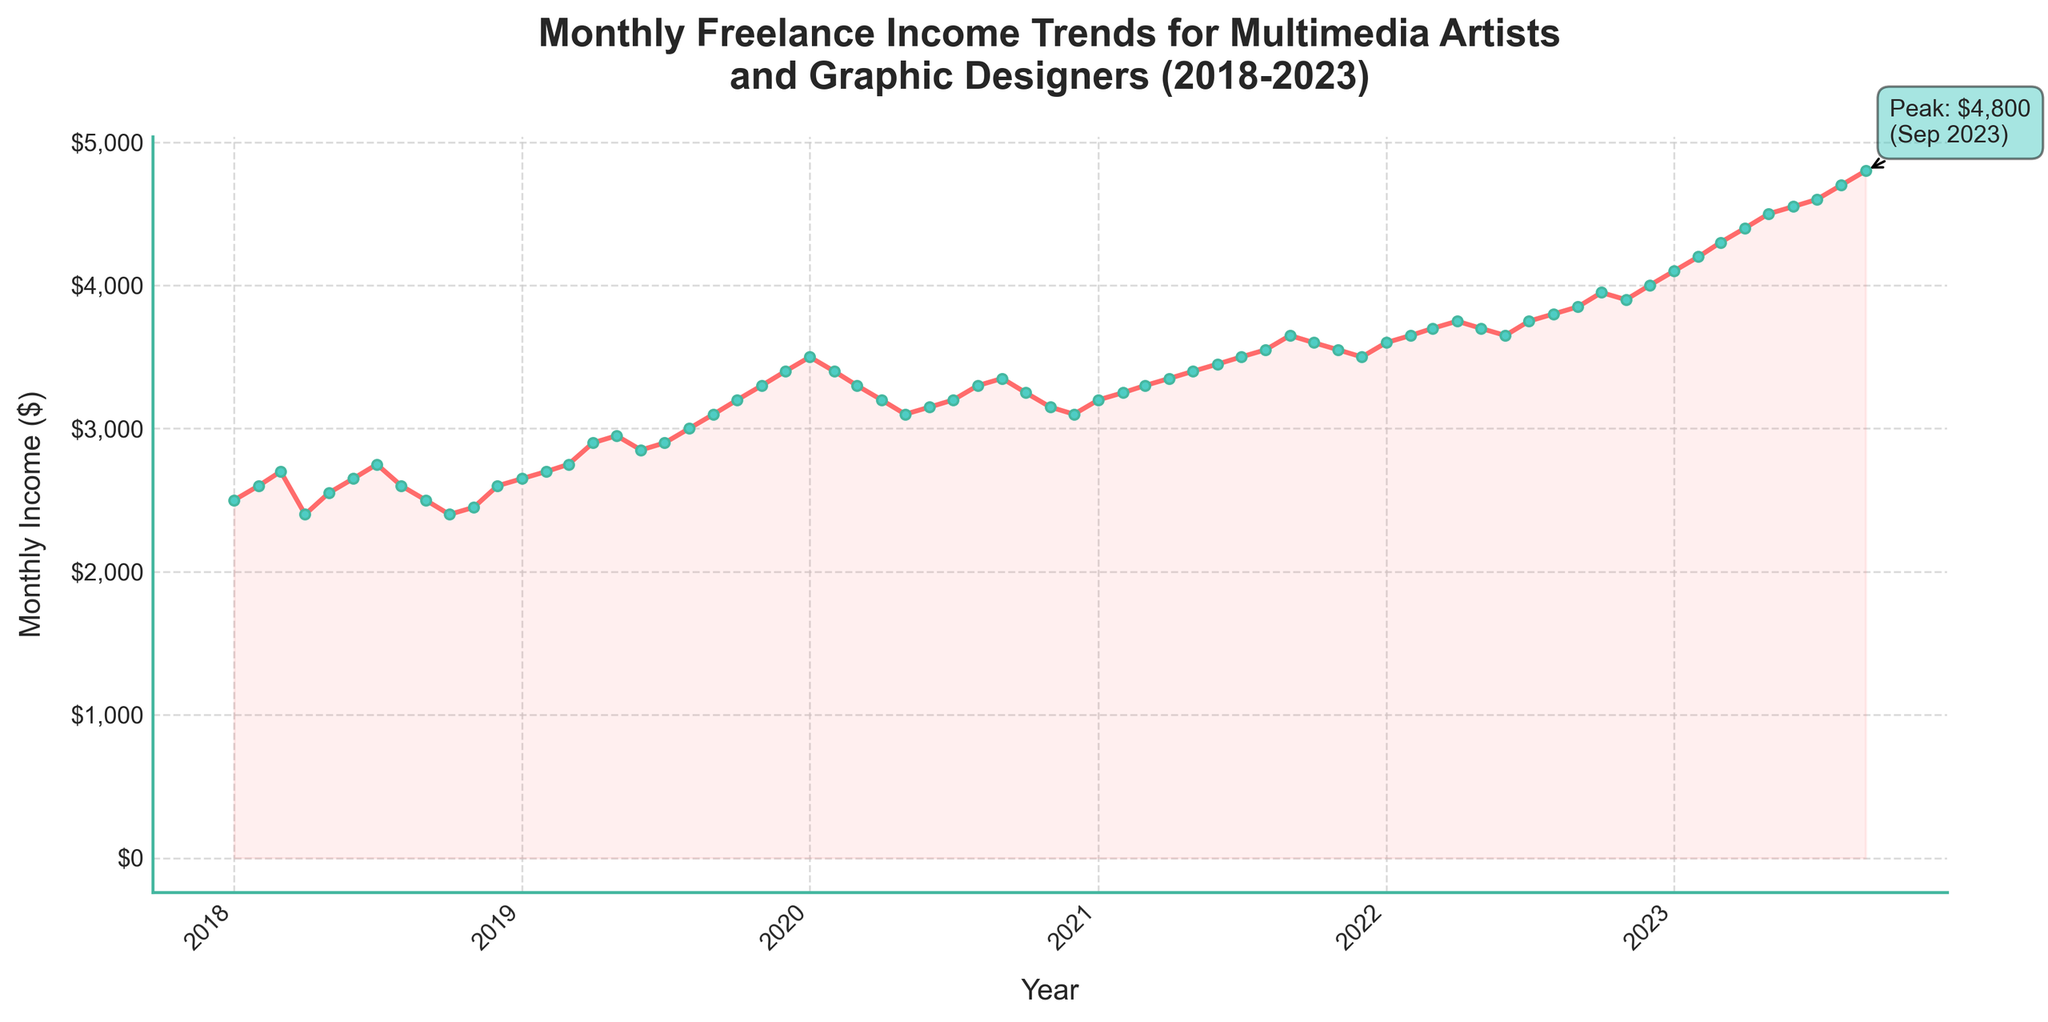What's the title of the figure? The title is located at the top of the figure, typically in a larger and bolder font. Reading this title provides the key context for the data being visualized.
Answer: Monthly Freelance Income Trends for Multimedia Artists and Graphic Designers (2018-2023) What is the highest monthly income in the time series? The highest point in the time series graph, which is annotated with a peak value, marks the highest income.
Answer: $4,800 How has the income trended from the start to the end of the timeline? By observing the start and end points of the line on the time series, we can see the general direction of the trend—whether it is increasing, decreasing, or stable. In this case, compare the initial and final data points.
Answer: Increased Which year shows a significant upward trend in income starting from January? Look for the year where there is a noticeable increase in income starting from January and over a few subsequent months compared to previous years.
Answer: 2019 What's the income difference between January 2018 and January 2023? Identify and compare the data points for January 2018 and January 2023 from the time series to calculate the difference. Income in January 2018 is $2,500, and in January 2023, it is $4,100. The difference is $4,100 - $2,500.
Answer: $1,600 In which months does income appear to be consistently lower? By visually following the time series line, identify recurring dips or lower points across the same months over different years.
Answer: October and November What was the average income for the year 2020? Calculate the mean of all the monthly income values for the year 2020. Sum the monthly values for 2020 and divide by the number of months (12).
Answer: $3,250 Between which consecutive months in 2022 did the income increase the most? Compare the increase in income from each month to the next within 2022 and identify the largest difference. For example, check changes between Jan-Feb, Feb-Mar, etc.
Answer: February and March How does the income in August 2023 compare to that in January 2022? Compare the income values of August 2023 and January 2022 directly from the plot. The values are $4,700 and $3,600 respectively.
Answer: Higher by $1,100 In which year was the change in income the most volatile? Look for the year with the most fluctuations (large peaks and troughs) in the line graph. This is seen by comparing the steepness of the changes within each year.
Answer: 2020 